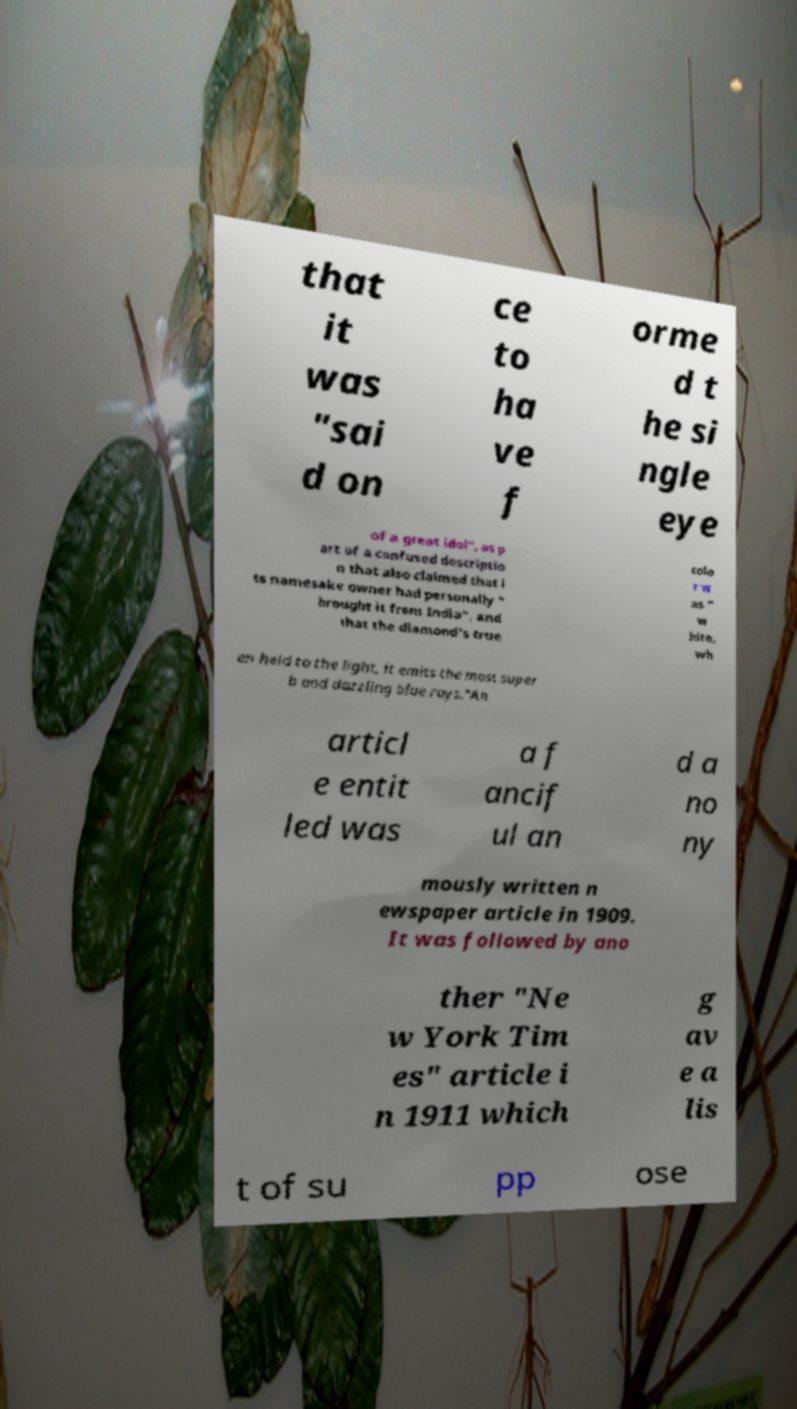I need the written content from this picture converted into text. Can you do that? that it was "sai d on ce to ha ve f orme d t he si ngle eye of a great idol", as p art of a confused descriptio n that also claimed that i ts namesake owner had personally " brought it from India", and that the diamond's true colo r w as " w hite, wh en held to the light, it emits the most super b and dazzling blue rays."An articl e entit led was a f ancif ul an d a no ny mously written n ewspaper article in 1909. It was followed by ano ther "Ne w York Tim es" article i n 1911 which g av e a lis t of su pp ose 